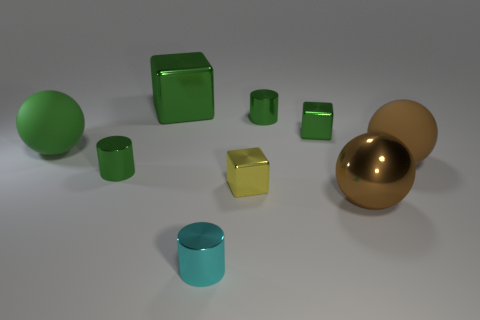Add 1 balls. How many objects exist? 10 Subtract all brown blocks. Subtract all gray cylinders. How many blocks are left? 3 Subtract all cylinders. How many objects are left? 6 Subtract 2 green cylinders. How many objects are left? 7 Subtract all big green matte balls. Subtract all brown shiny spheres. How many objects are left? 7 Add 7 cylinders. How many cylinders are left? 10 Add 7 brown metal spheres. How many brown metal spheres exist? 8 